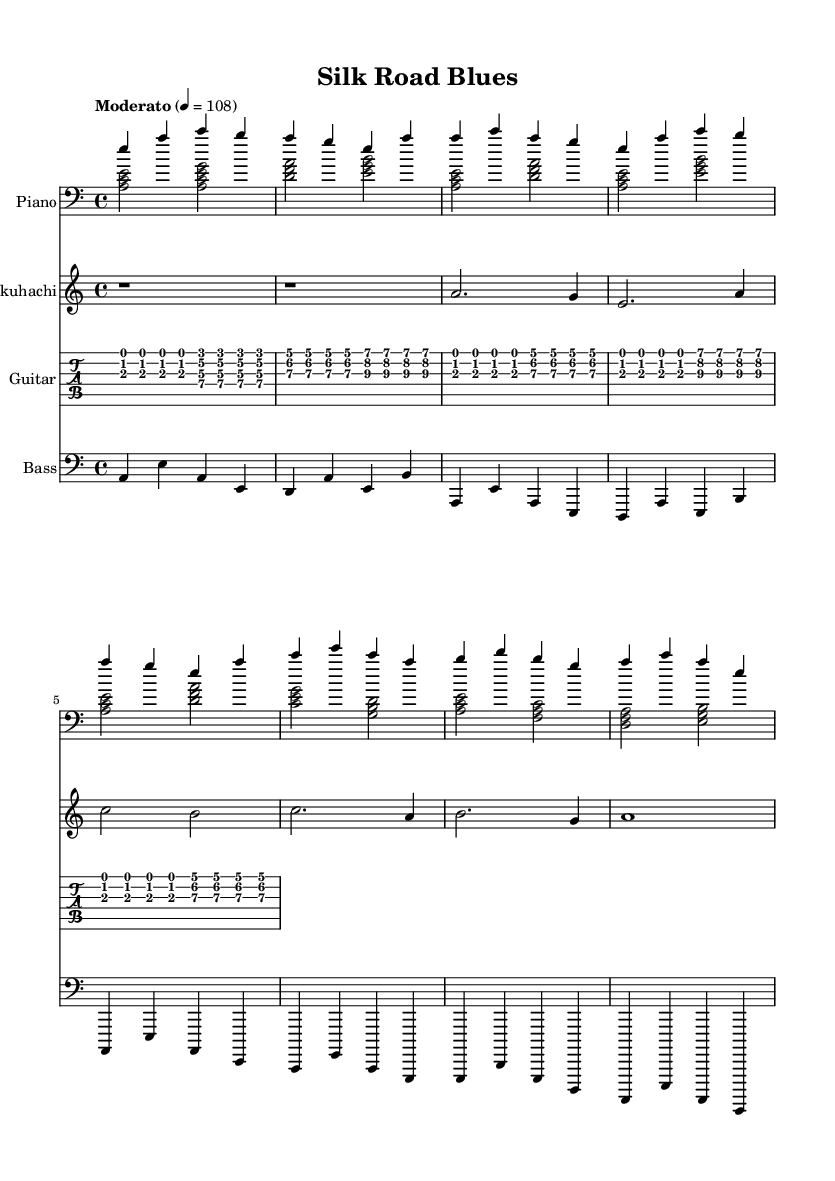What is the key signature of this music? The key signature is A minor, indicated by the absence of sharps or flats in the music sheet. A minor shares the same key signature as C major.
Answer: A minor What is the time signature of this music? The time signature is 4/4, which is commonly used in Blues music. It indicates four beats in a measure, with each beat being a quarter note.
Answer: 4/4 What is the tempo marking of this music? The tempo marking is "Moderato," which indicates a moderate speed. The metronome marking of 108 means there are 108 beats per minute.
Answer: Moderato How many instruments are featured in this piece? The score shows four distinct instruments: Piano, Shakuhachi, Guitar, and Bass, each contributing different elements to the composition.
Answer: Four What structure does the music follow in the chorus section? The chorus consists of a progression that showcases call-and-response, a characteristic feature of Blues, where different instruments or voices respond to each other. The transitions within the chords also highlight this interaction.
Answer: Call-and-response Which instrument plays the lead melody in the introduction? The Shakuhachi is primarily used to convey the lead melody during the introduction, providing an Eastern cultural influence alongside the Western elements of the other instruments.
Answer: Shakuhachi What chord is played at the beginning of the verse? The first chord of the verse is A minor, which sets the tonal foundation for both the melody and harmony throughout the music.
Answer: A minor 